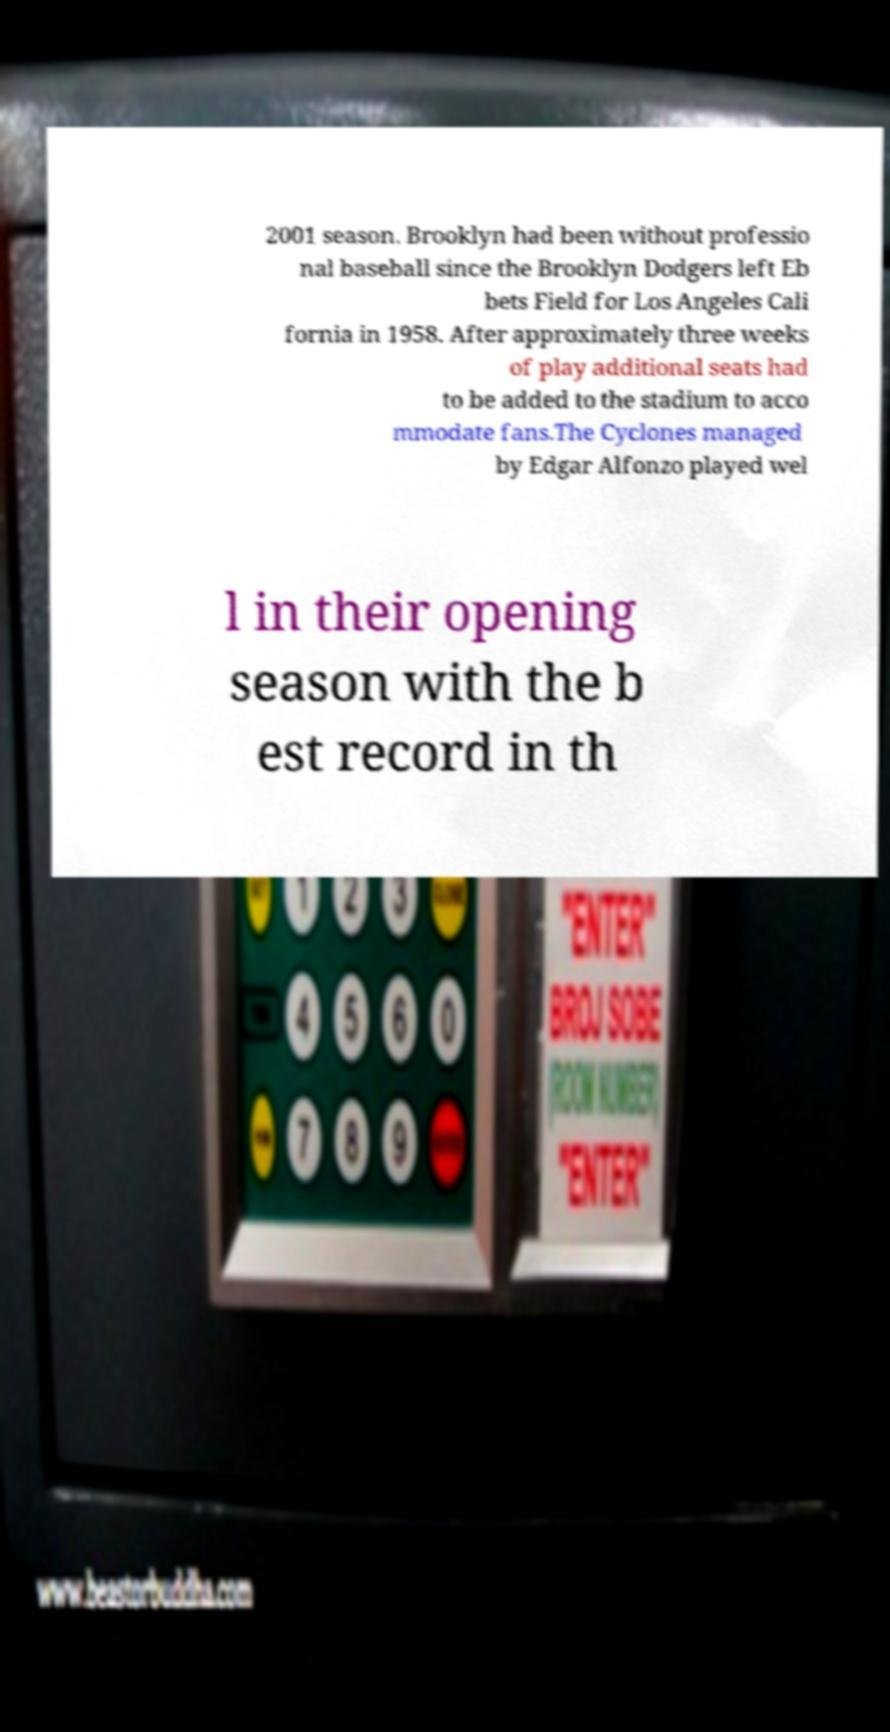There's text embedded in this image that I need extracted. Can you transcribe it verbatim? 2001 season. Brooklyn had been without professio nal baseball since the Brooklyn Dodgers left Eb bets Field for Los Angeles Cali fornia in 1958. After approximately three weeks of play additional seats had to be added to the stadium to acco mmodate fans.The Cyclones managed by Edgar Alfonzo played wel l in their opening season with the b est record in th 